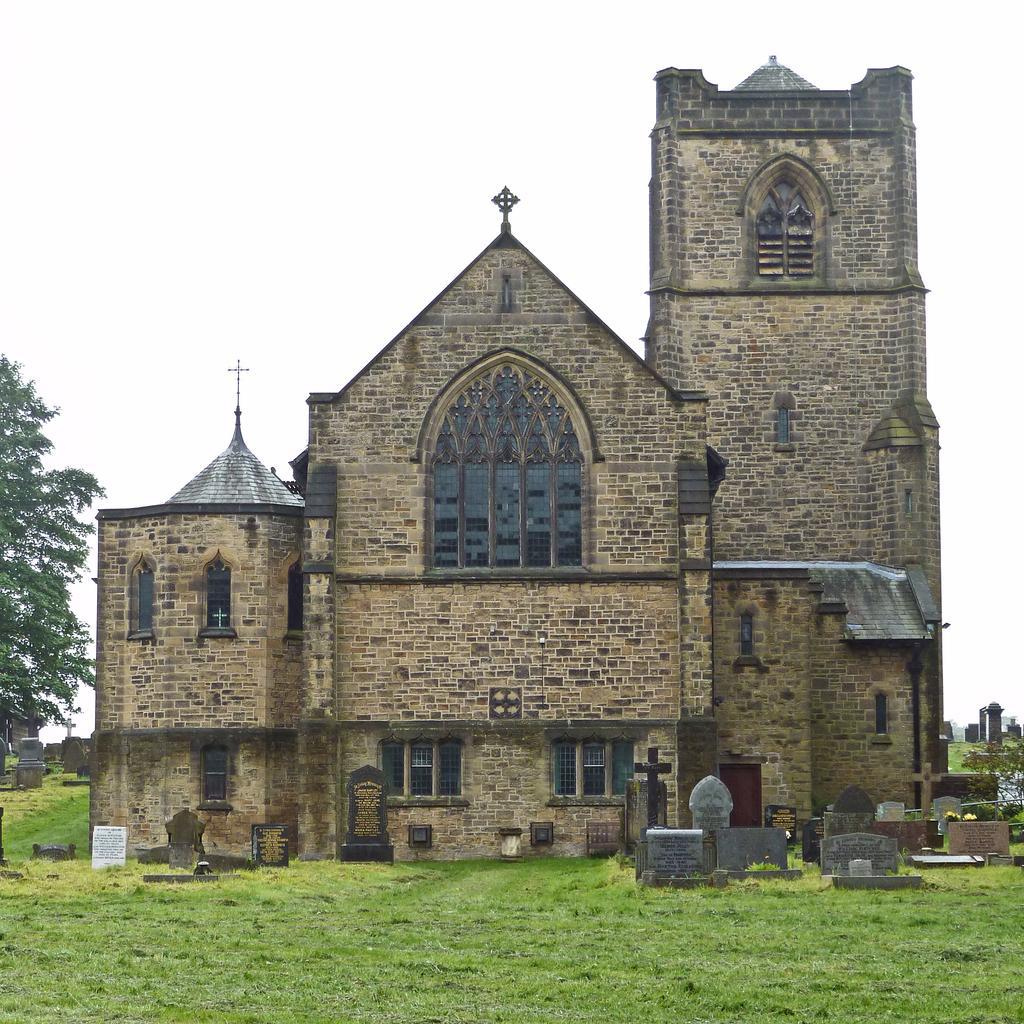Can you describe this image briefly? This picture is taken from the outside of the building. On the left side, we can see some trees. At the top, we can see a sky, at the bottom, we can see planets and a grass. 